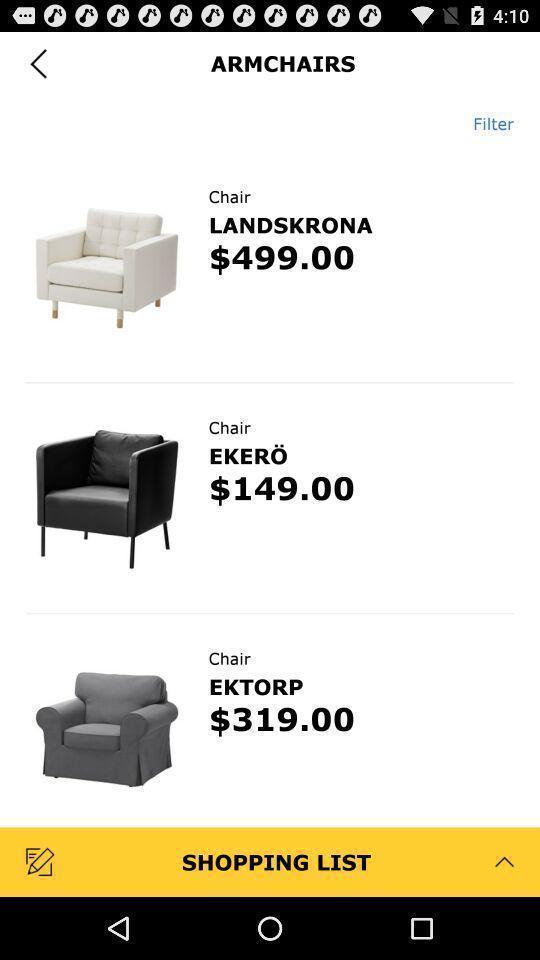Describe the key features of this screenshot. Products in the shopping list. 